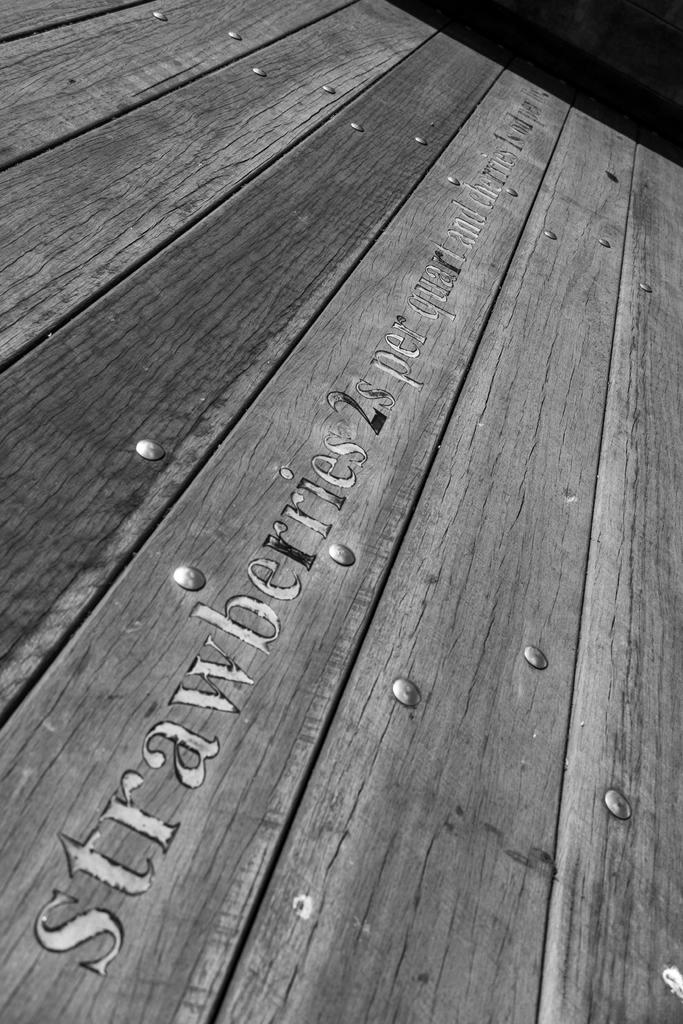What fruit is being sold?
Give a very brief answer. Strawberries. How much are the strawberries?
Your response must be concise. 2s per quart. 